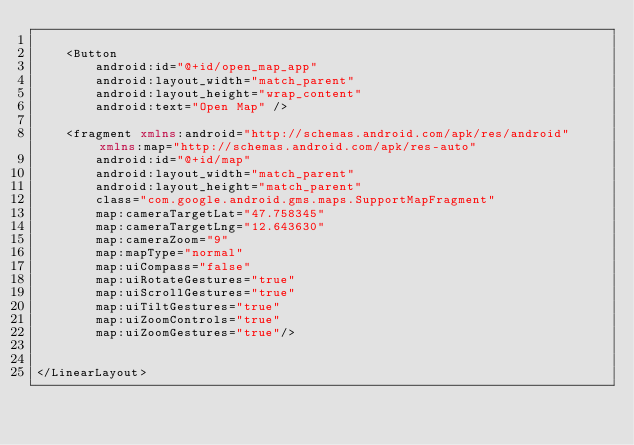Convert code to text. <code><loc_0><loc_0><loc_500><loc_500><_XML_>
    <Button
        android:id="@+id/open_map_app"
        android:layout_width="match_parent"
        android:layout_height="wrap_content"
        android:text="Open Map" />

    <fragment xmlns:android="http://schemas.android.com/apk/res/android" xmlns:map="http://schemas.android.com/apk/res-auto"
        android:id="@+id/map"
        android:layout_width="match_parent"
        android:layout_height="match_parent"
        class="com.google.android.gms.maps.SupportMapFragment"
        map:cameraTargetLat="47.758345"
        map:cameraTargetLng="12.643630"
        map:cameraZoom="9"
        map:mapType="normal"
        map:uiCompass="false"
        map:uiRotateGestures="true"
        map:uiScrollGestures="true"
        map:uiTiltGestures="true"
        map:uiZoomControls="true"
        map:uiZoomGestures="true"/>


</LinearLayout>
</code> 